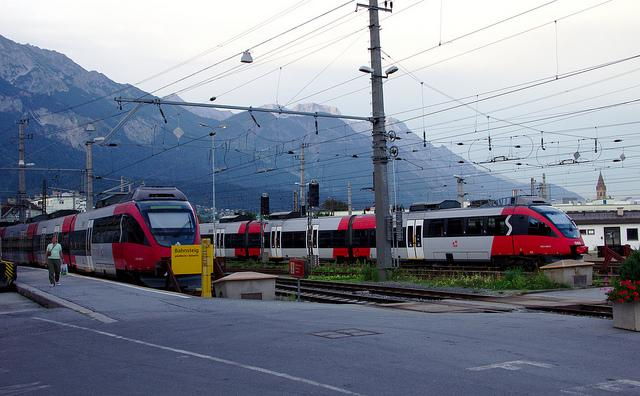What helps for transponders to communicate with the cab and train control systems? radio 